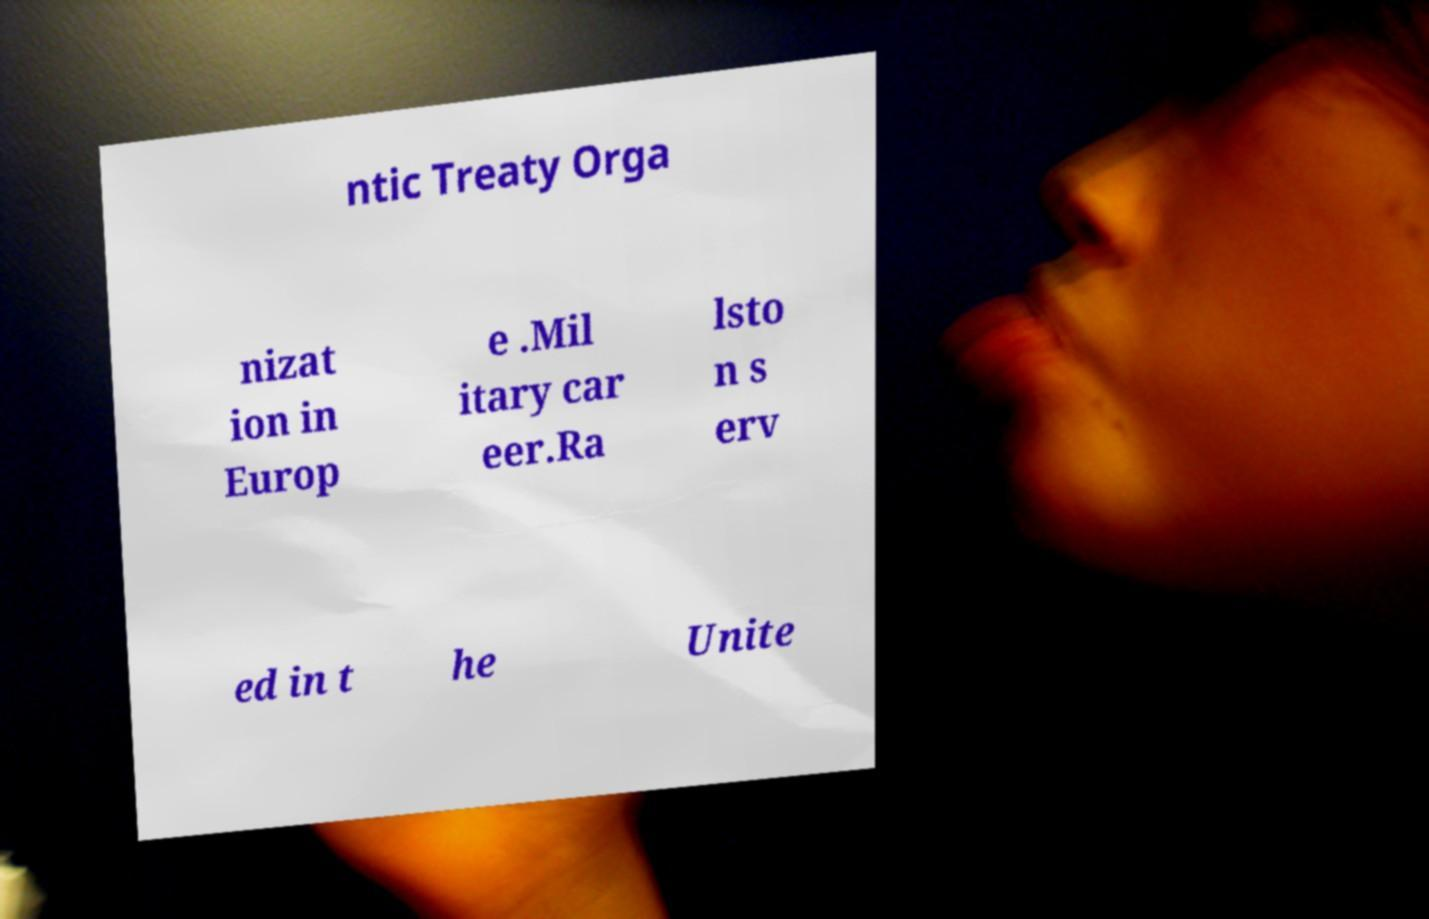What messages or text are displayed in this image? I need them in a readable, typed format. ntic Treaty Orga nizat ion in Europ e .Mil itary car eer.Ra lsto n s erv ed in t he Unite 